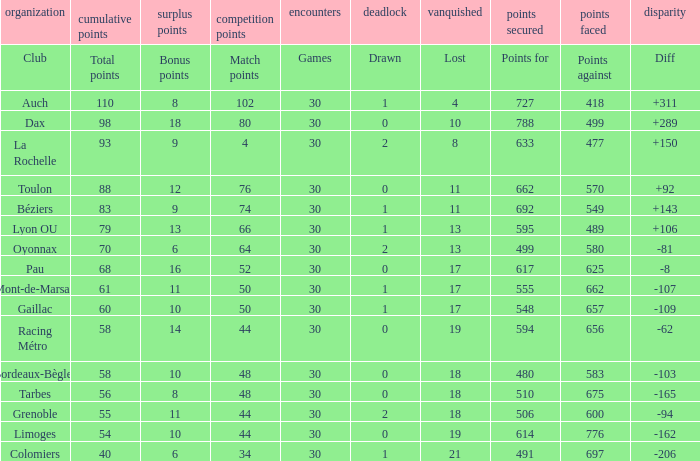What is the amount of match points for a club that lost 18 and has 11 bonus points? 44.0. 